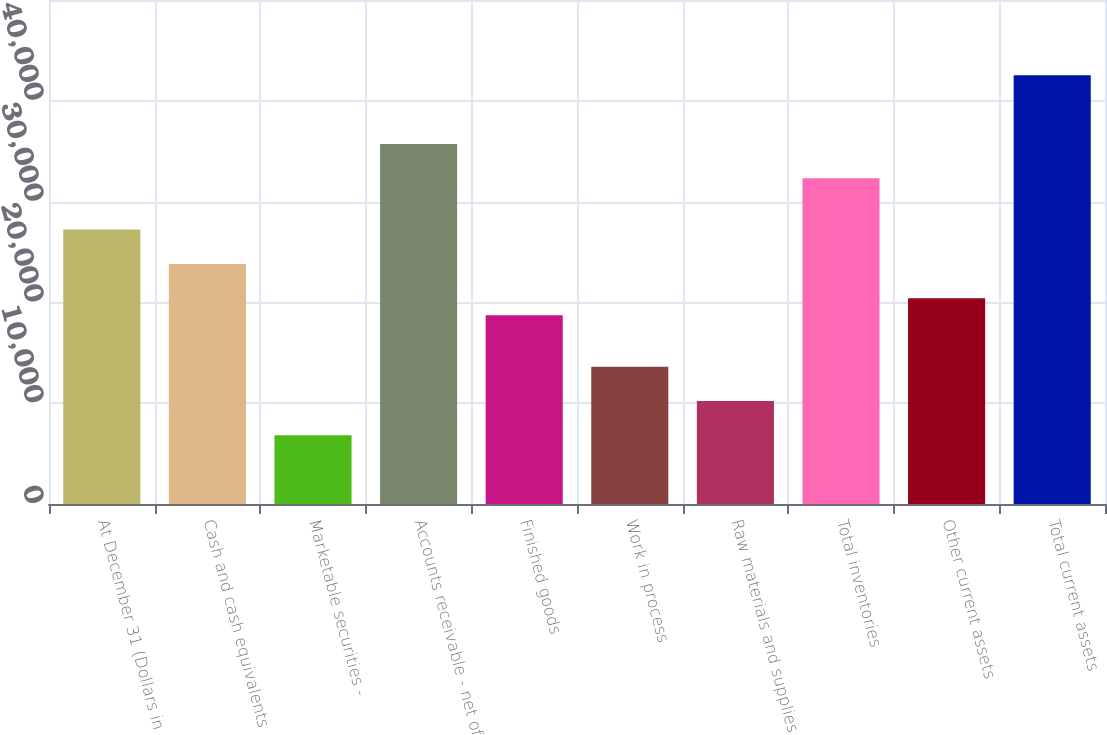Convert chart. <chart><loc_0><loc_0><loc_500><loc_500><bar_chart><fcel>At December 31 (Dollars in<fcel>Cash and cash equivalents<fcel>Marketable securities -<fcel>Accounts receivable - net of<fcel>Finished goods<fcel>Work in process<fcel>Raw materials and supplies<fcel>Total inventories<fcel>Other current assets<fcel>Total current assets<nl><fcel>27221.8<fcel>23820.2<fcel>6812.2<fcel>35725.8<fcel>18717.8<fcel>13615.4<fcel>10213.8<fcel>32324.2<fcel>20418.6<fcel>42529<nl></chart> 